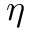Convert formula to latex. <formula><loc_0><loc_0><loc_500><loc_500>\eta</formula> 